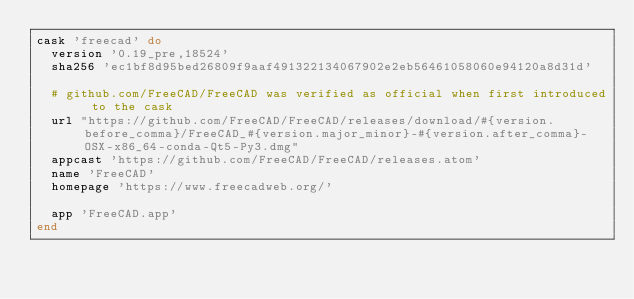Convert code to text. <code><loc_0><loc_0><loc_500><loc_500><_Ruby_>cask 'freecad' do
  version '0.19_pre,18524'
  sha256 'ec1bf8d95bed26809f9aaf491322134067902e2eb56461058060e94120a8d31d'

  # github.com/FreeCAD/FreeCAD was verified as official when first introduced to the cask
  url "https://github.com/FreeCAD/FreeCAD/releases/download/#{version.before_comma}/FreeCAD_#{version.major_minor}-#{version.after_comma}-OSX-x86_64-conda-Qt5-Py3.dmg"
  appcast 'https://github.com/FreeCAD/FreeCAD/releases.atom'
  name 'FreeCAD'
  homepage 'https://www.freecadweb.org/'

  app 'FreeCAD.app'
end
</code> 